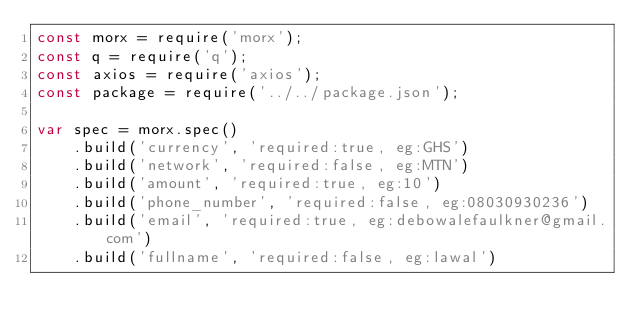<code> <loc_0><loc_0><loc_500><loc_500><_JavaScript_>const morx = require('morx');
const q = require('q');
const axios = require('axios');
const package = require('../../package.json');

var spec = morx.spec()
	.build('currency', 'required:true, eg:GHS')
	.build('network', 'required:false, eg:MTN')
	.build('amount', 'required:true, eg:10')
	.build('phone_number', 'required:false, eg:08030930236')
	.build('email', 'required:true, eg:debowalefaulkner@gmail.com')
	.build('fullname', 'required:false, eg:lawal')</code> 